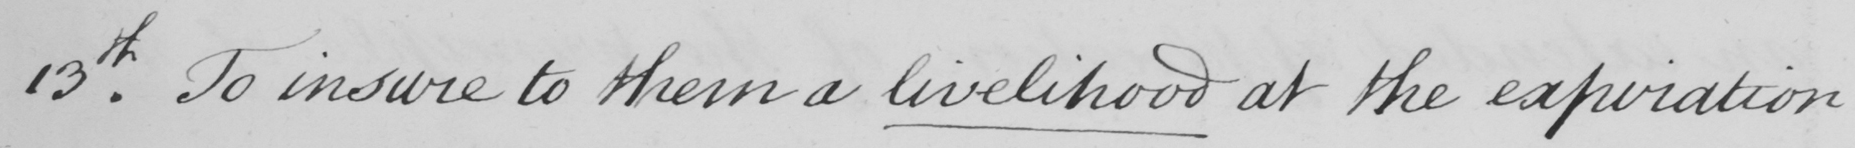Please transcribe the handwritten text in this image. 13th . To insure to them a livelihood at the expiration 